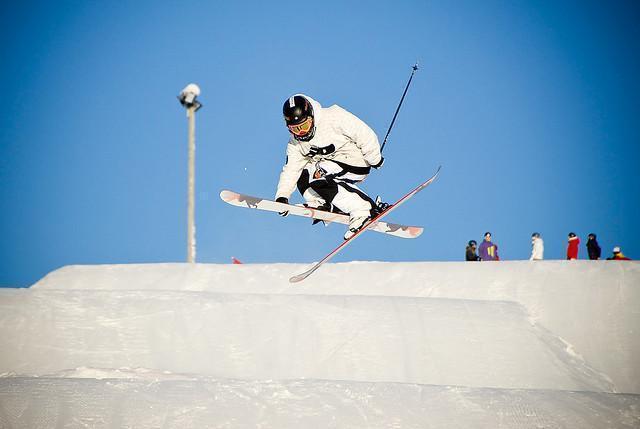Why is the man holding onto the ski?
Choose the correct response, then elucidate: 'Answer: answer
Rationale: rationale.'
Options: Performing trick, cleaning it, waxing it, unlatching. Answer: performing trick.
Rationale: The man appears in the air and appears to have gone over a jump. skiers who are airborne over a jump are likely intending to perform a skill. 